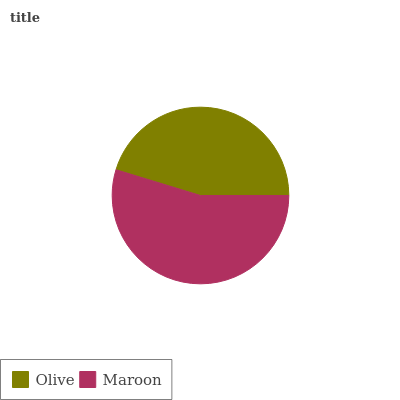Is Olive the minimum?
Answer yes or no. Yes. Is Maroon the maximum?
Answer yes or no. Yes. Is Maroon the minimum?
Answer yes or no. No. Is Maroon greater than Olive?
Answer yes or no. Yes. Is Olive less than Maroon?
Answer yes or no. Yes. Is Olive greater than Maroon?
Answer yes or no. No. Is Maroon less than Olive?
Answer yes or no. No. Is Maroon the high median?
Answer yes or no. Yes. Is Olive the low median?
Answer yes or no. Yes. Is Olive the high median?
Answer yes or no. No. Is Maroon the low median?
Answer yes or no. No. 